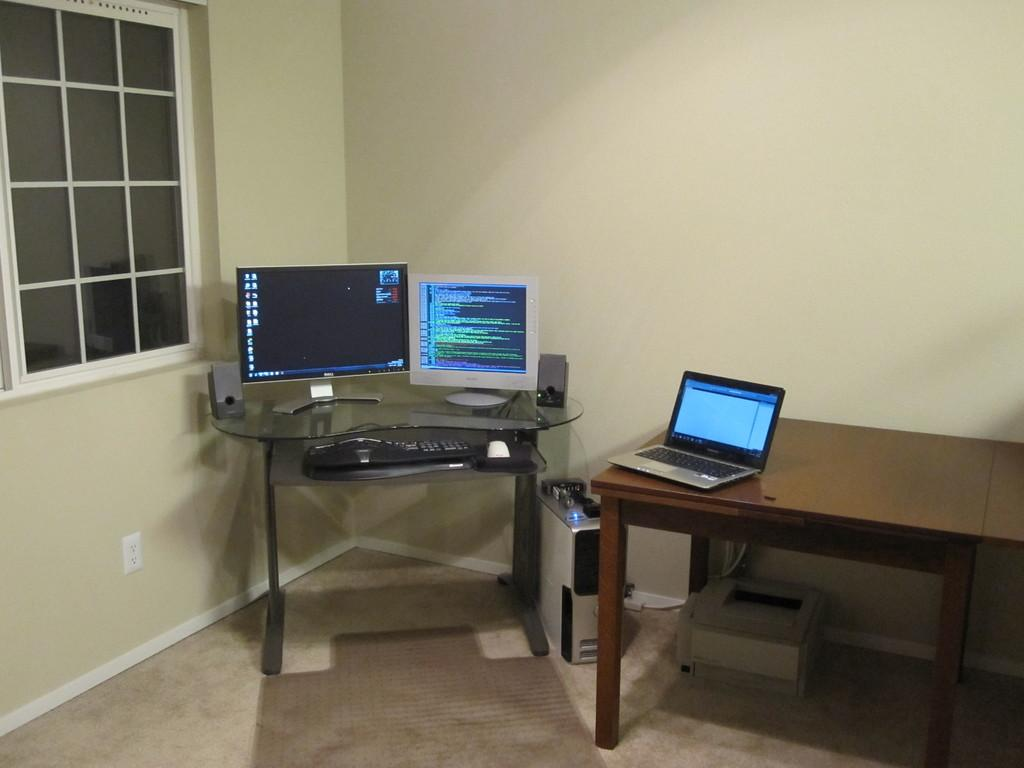What electronic device is on the table in the image? There is a laptop on the table in the image. What other device is located under the table? There is a printer under the table in the image. How many monitors are present in the image? There are monitors present in the image. What input device is visible in the image? There is a keyboard in the image. What type of communication device is present in the image? There is a mobile in the image. What is the main processing unit of the computer system in the image? There is a CPU in the image. What can be seen in the background of the image? There is a window in the image. What type of seat is visible in the image? There is no seat visible in the image. Can you tell me how many holes are in the laptop? The laptop does not have any holes in the image. What type of lunch is being prepared in the image? There is no indication of any lunch preparation in the image. 